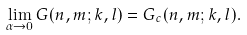Convert formula to latex. <formula><loc_0><loc_0><loc_500><loc_500>\lim _ { \alpha \rightarrow 0 } G ( n , m ; k , l ) = G _ { c } ( n , m ; k , l ) .</formula> 